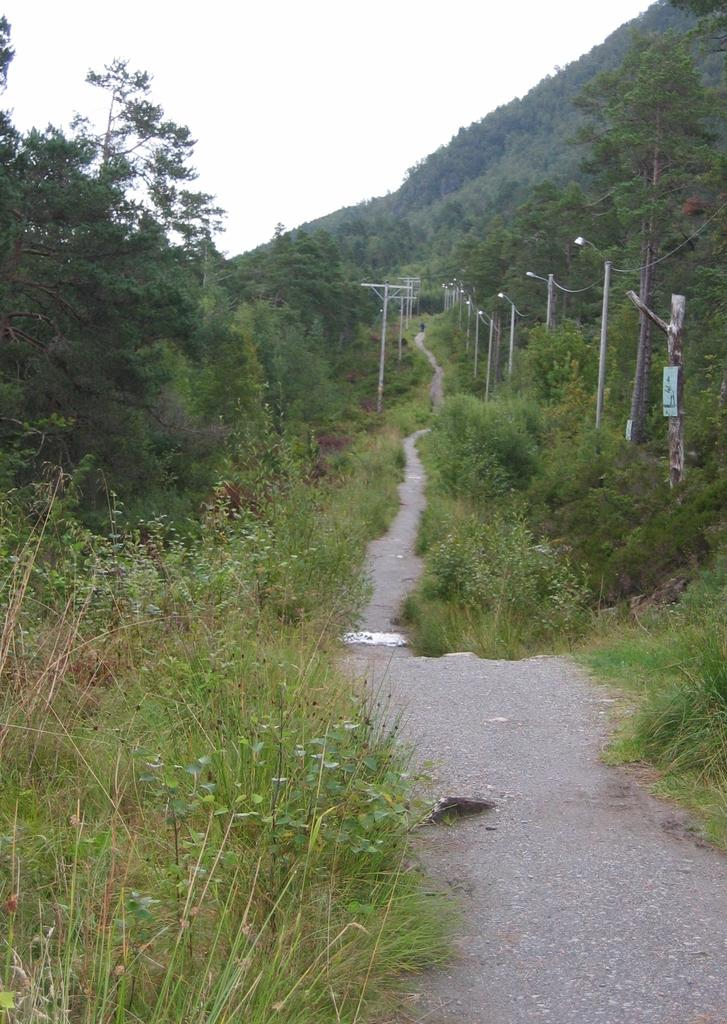What type of vegetation is present in the image? There is grass in the image. What type of pathway can be seen in the image? There is a road in the image. What structures are present in the image? There are poles in the image. What other natural elements can be seen in the image? There are trees in the image. What is visible at the top of the image? The sky is visible at the top of the image. What geographical feature is on the right side of the image? There is a hill on the right side of the image. Where is the shop located in the image? There is no shop present in the image. What type of mark can be seen on the hill in the image? There is no mark visible on the hill in the image. 